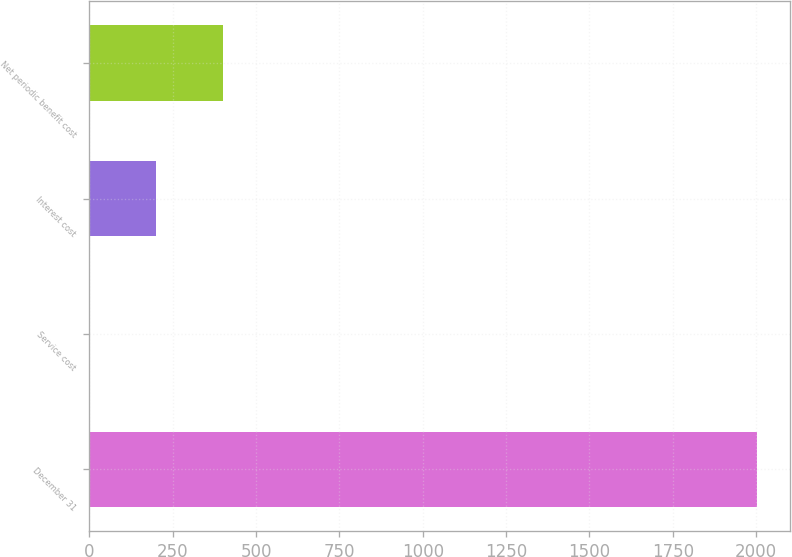Convert chart to OTSL. <chart><loc_0><loc_0><loc_500><loc_500><bar_chart><fcel>December 31<fcel>Service cost<fcel>Interest cost<fcel>Net periodic benefit cost<nl><fcel>2002<fcel>1.1<fcel>201.19<fcel>401.28<nl></chart> 